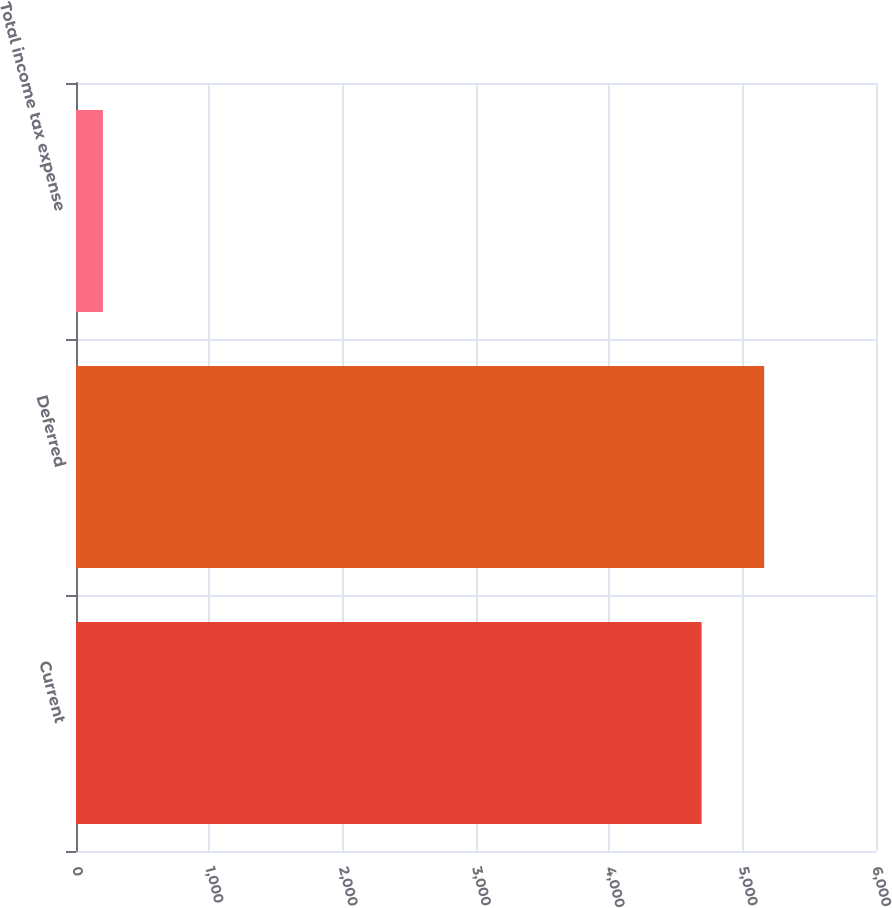<chart> <loc_0><loc_0><loc_500><loc_500><bar_chart><fcel>Current<fcel>Deferred<fcel>Total income tax expense<nl><fcel>4692<fcel>5161.2<fcel>202<nl></chart> 